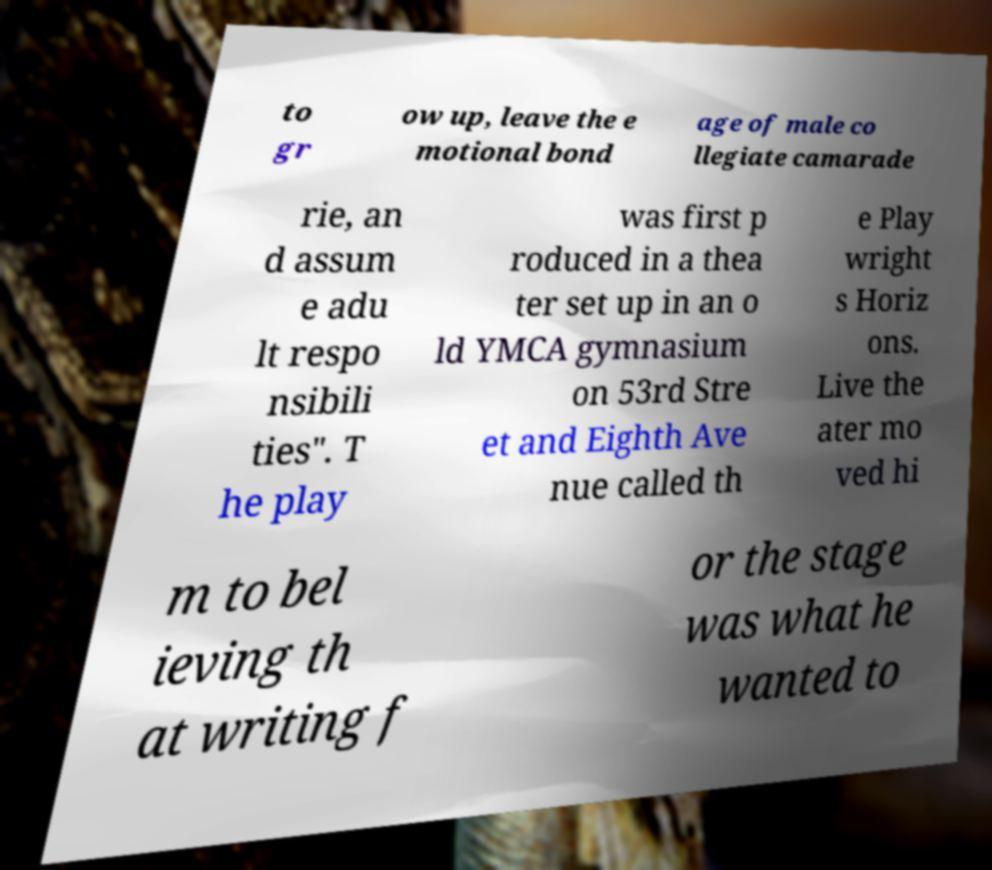I need the written content from this picture converted into text. Can you do that? to gr ow up, leave the e motional bond age of male co llegiate camarade rie, an d assum e adu lt respo nsibili ties". T he play was first p roduced in a thea ter set up in an o ld YMCA gymnasium on 53rd Stre et and Eighth Ave nue called th e Play wright s Horiz ons. Live the ater mo ved hi m to bel ieving th at writing f or the stage was what he wanted to 